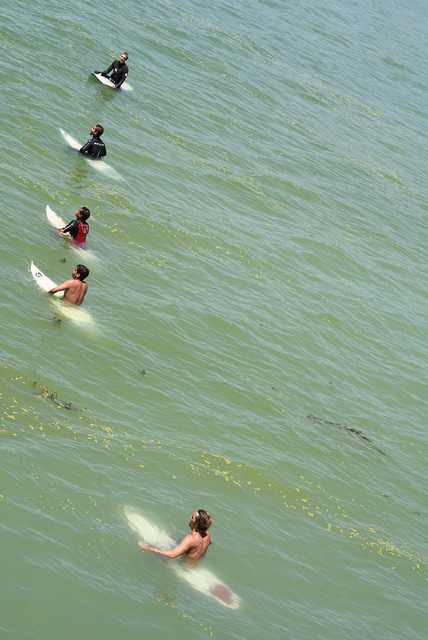Are all the people in this scene facing in the same direction? Yes, all individuals in the image are facing towards the ocean, likely in anticipation of catching incoming waves. 